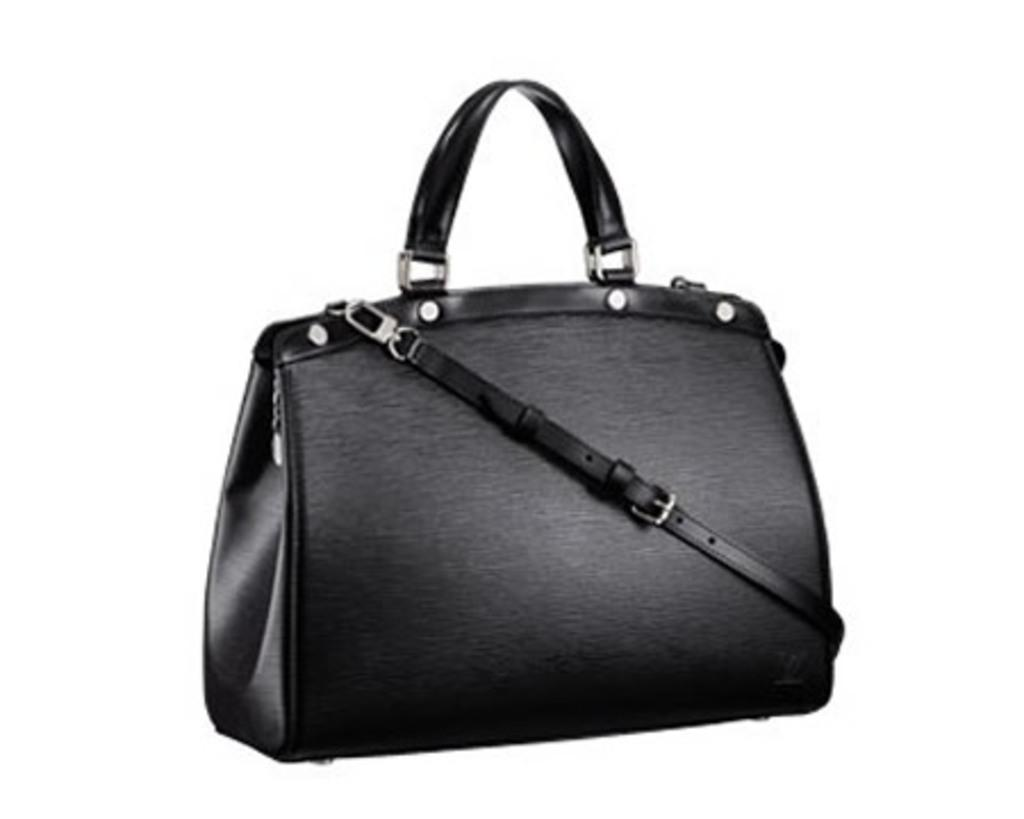What type of accessory is in the center of the image? There is a black handbag in the center of the image. Can you describe the position of the handbag in the image? The handbag is in the center of the image. What type of vacation is the handbag planning for the summer? The handbag is not a living being and therefore cannot plan vacations. 